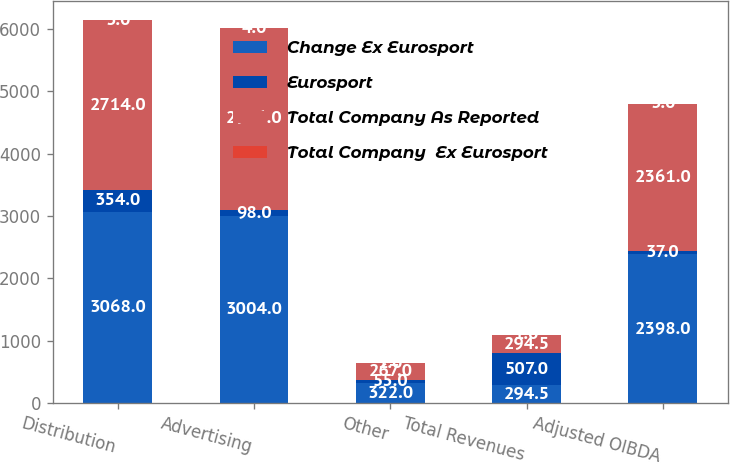<chart> <loc_0><loc_0><loc_500><loc_500><stacked_bar_chart><ecel><fcel>Distribution<fcel>Advertising<fcel>Other<fcel>Total Revenues<fcel>Adjusted OIBDA<nl><fcel>Change Ex Eurosport<fcel>3068<fcel>3004<fcel>322<fcel>294.5<fcel>2398<nl><fcel>Eurosport<fcel>354<fcel>98<fcel>55<fcel>507<fcel>37<nl><fcel>Total Company As Reported<fcel>2714<fcel>2906<fcel>267<fcel>294.5<fcel>2361<nl><fcel>Total Company  Ex Eurosport<fcel>3<fcel>4<fcel>1<fcel>1<fcel>3<nl></chart> 